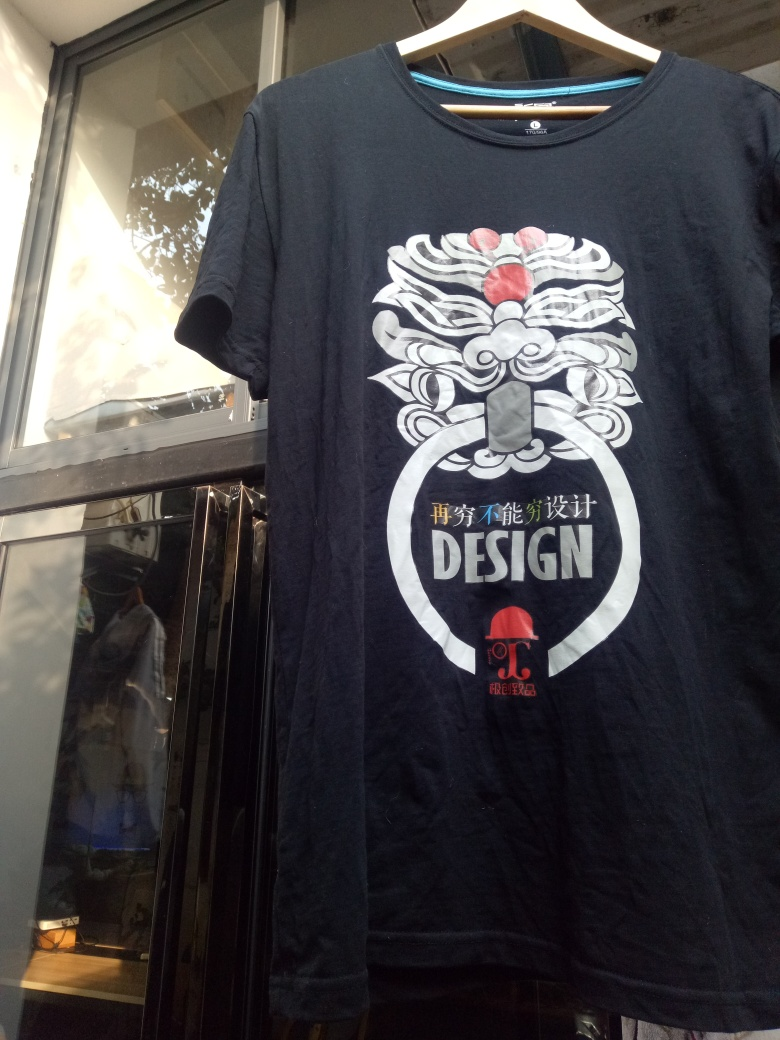Is the lighting in the photo bright? The lighting in the photo is moderately bright, primarily illuminating the top section of the T-shirt on display and casting a soft glare on the window pane behind it. Although the light is not overly intense, it is sufficient to clearly reveal the design features on the T-shirt. 